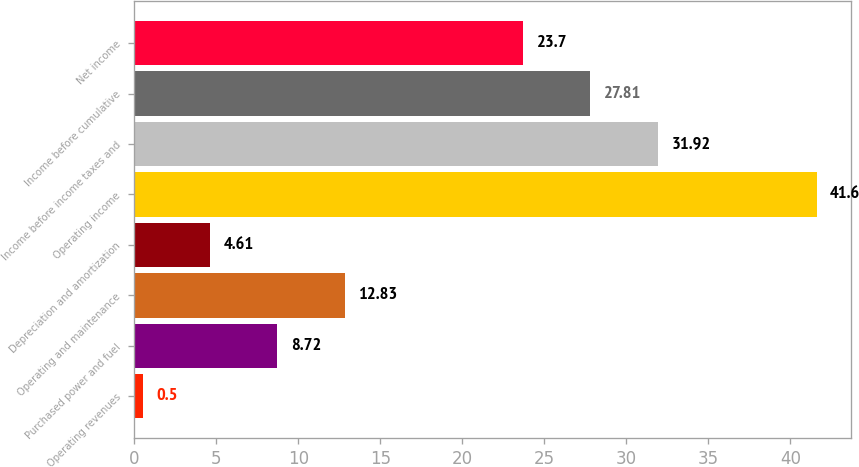Convert chart. <chart><loc_0><loc_0><loc_500><loc_500><bar_chart><fcel>Operating revenues<fcel>Purchased power and fuel<fcel>Operating and maintenance<fcel>Depreciation and amortization<fcel>Operating income<fcel>Income before income taxes and<fcel>Income before cumulative<fcel>Net income<nl><fcel>0.5<fcel>8.72<fcel>12.83<fcel>4.61<fcel>41.6<fcel>31.92<fcel>27.81<fcel>23.7<nl></chart> 